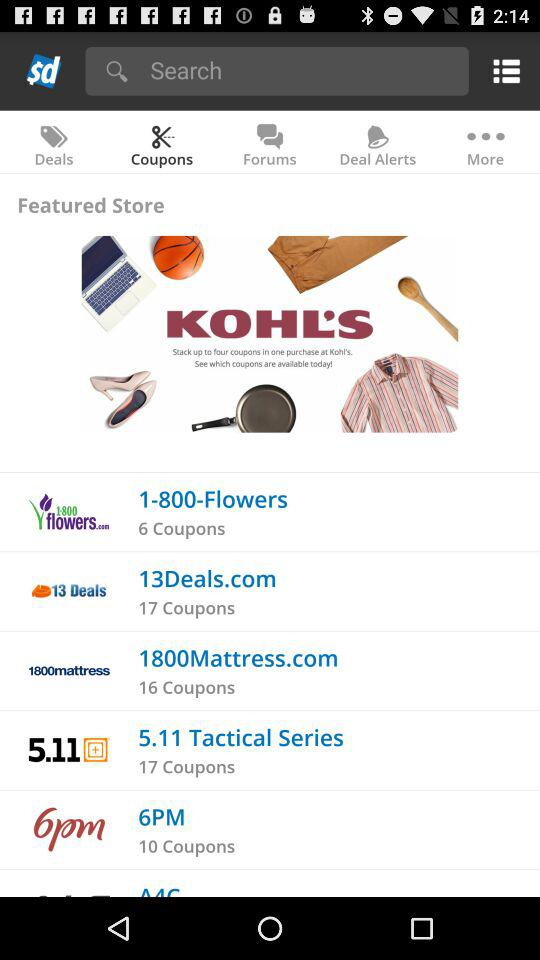How many coupons are there for "1-800-Flowers"? There are 6 coupons for "1-800-Flowers". 